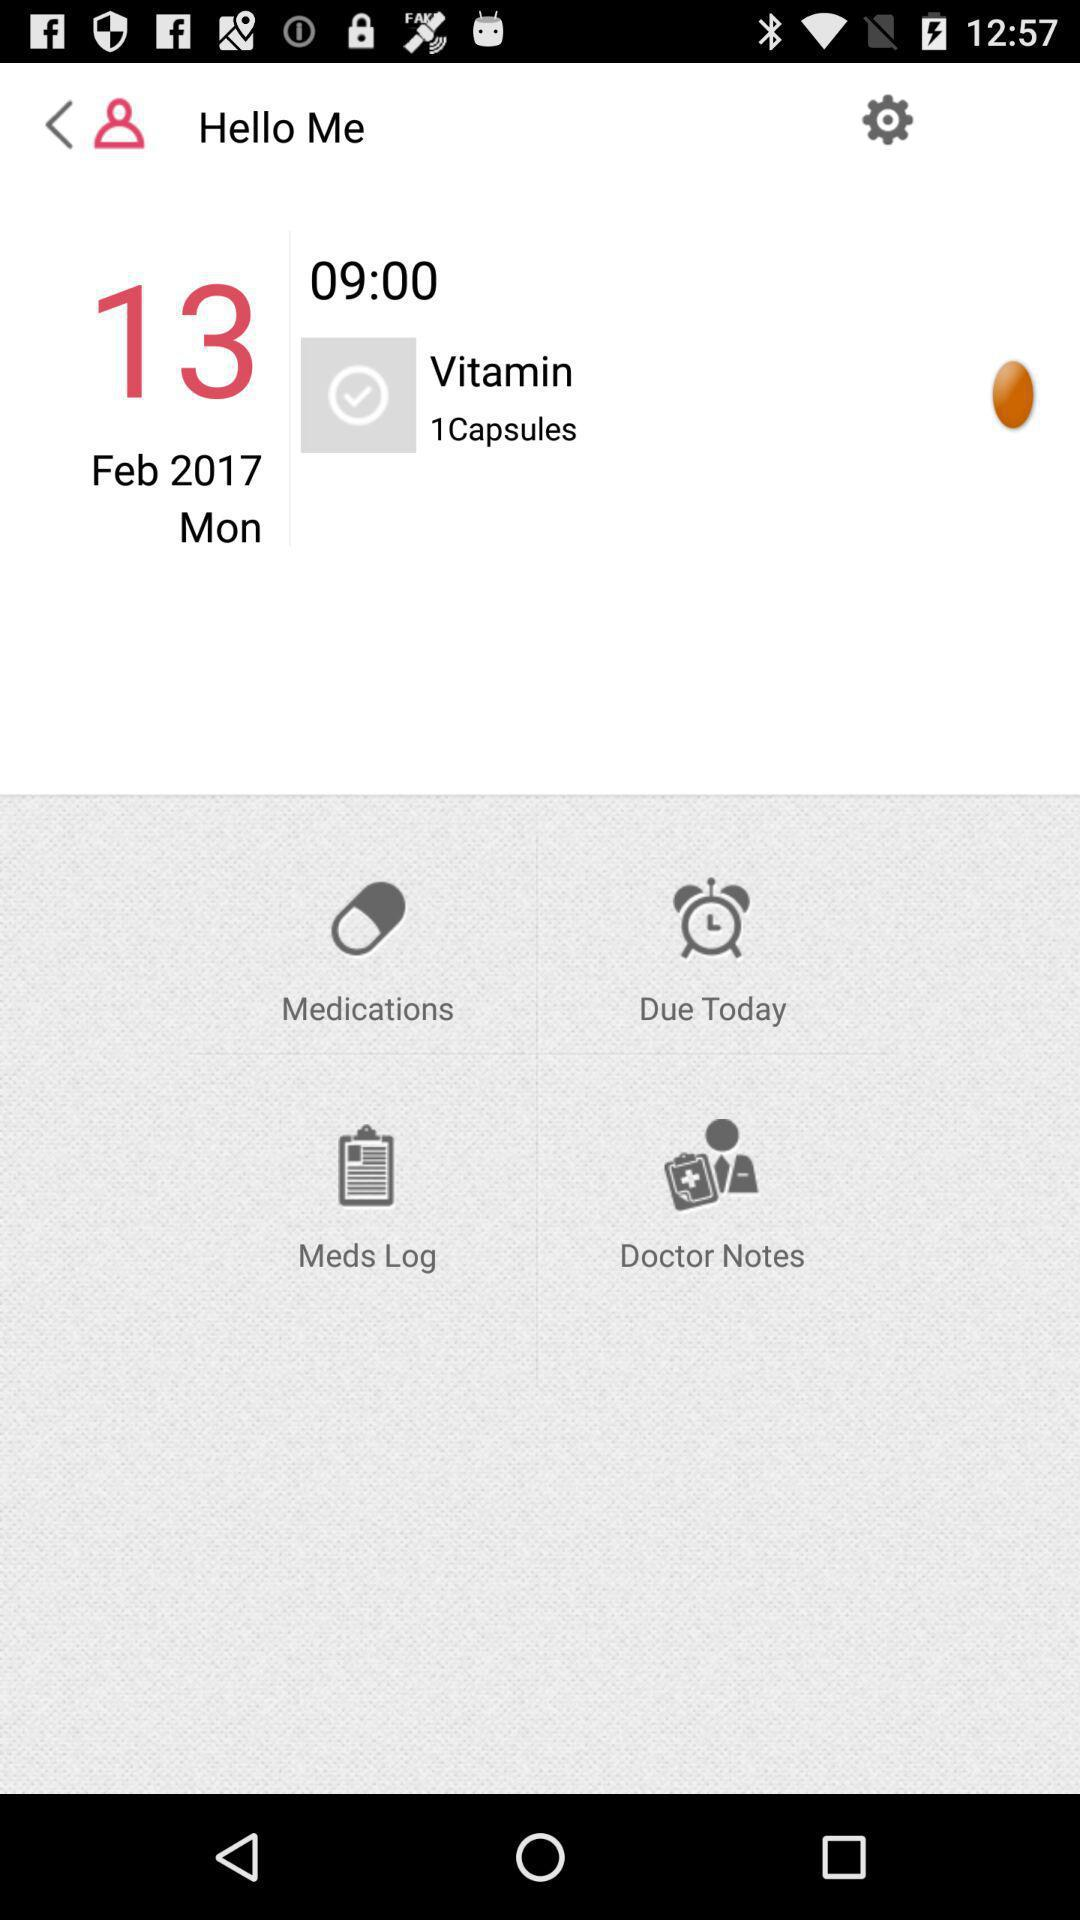What is the date to take vitamin capsules? The date is Monday, February 13, 2017. 